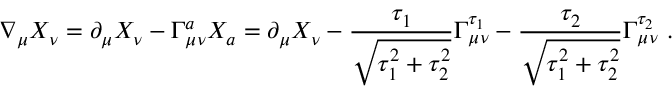Convert formula to latex. <formula><loc_0><loc_0><loc_500><loc_500>\nabla _ { \mu } X _ { \nu } = \partial _ { \mu } X _ { \nu } - \Gamma _ { \mu \nu } ^ { a } X _ { a } = \partial _ { \mu } X _ { \nu } - \frac { \tau _ { 1 } } { \sqrt { \tau _ { 1 } ^ { 2 } + \tau _ { 2 } ^ { 2 } } } \Gamma _ { \mu \nu } ^ { \tau _ { 1 } } - \frac { \tau _ { 2 } } { \sqrt { \tau _ { 1 } ^ { 2 } + \tau _ { 2 } ^ { 2 } } } \Gamma _ { \mu \nu } ^ { \tau _ { 2 } } \ .</formula> 